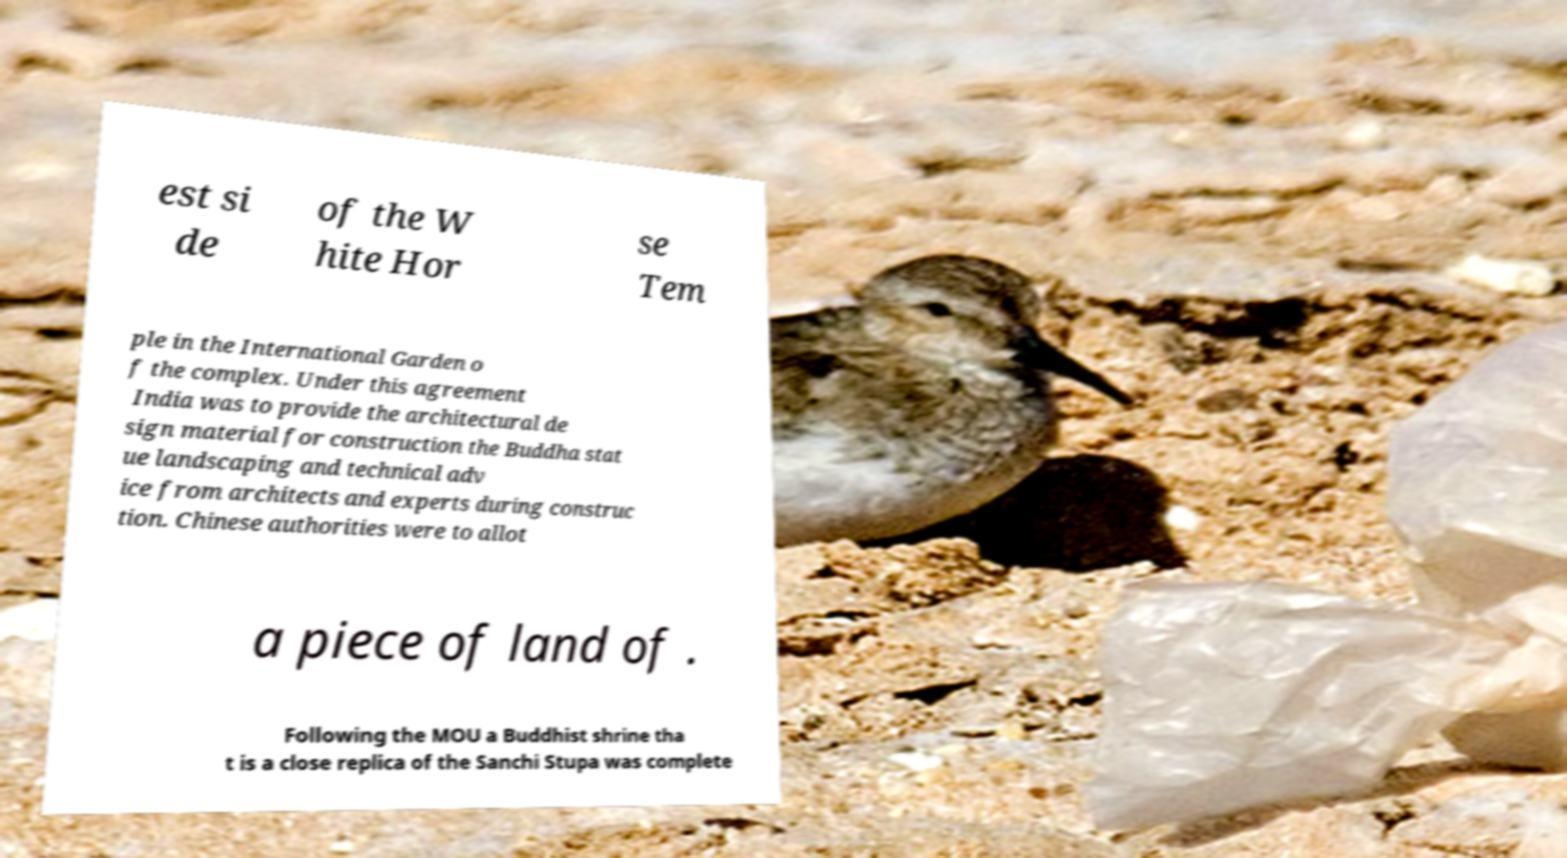For documentation purposes, I need the text within this image transcribed. Could you provide that? est si de of the W hite Hor se Tem ple in the International Garden o f the complex. Under this agreement India was to provide the architectural de sign material for construction the Buddha stat ue landscaping and technical adv ice from architects and experts during construc tion. Chinese authorities were to allot a piece of land of . Following the MOU a Buddhist shrine tha t is a close replica of the Sanchi Stupa was complete 